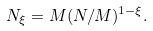Convert formula to latex. <formula><loc_0><loc_0><loc_500><loc_500>N _ { \xi } = M ( N / M ) ^ { 1 - \xi } .</formula> 